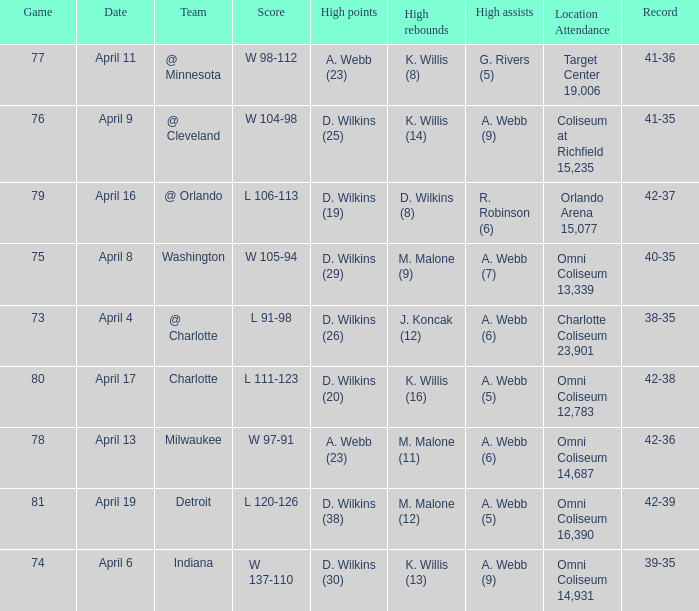What date was the game score w 104-98? April 9. 